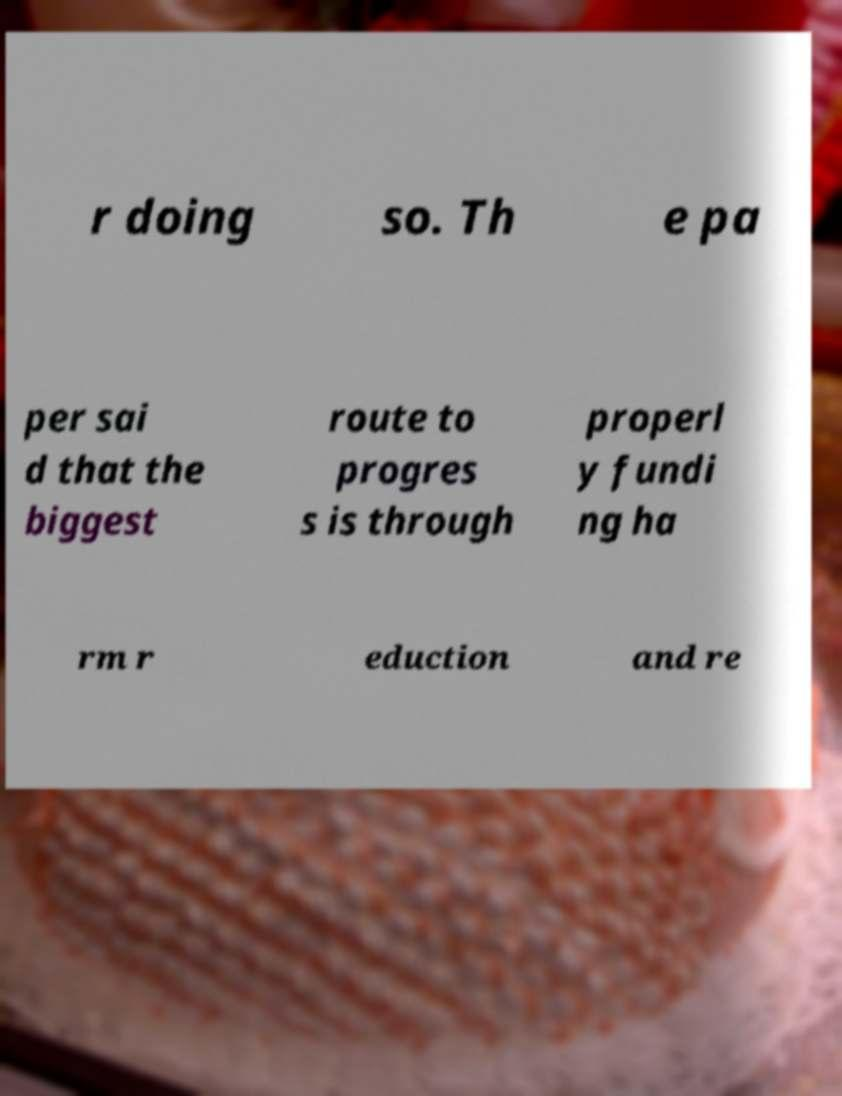Please read and relay the text visible in this image. What does it say? r doing so. Th e pa per sai d that the biggest route to progres s is through properl y fundi ng ha rm r eduction and re 